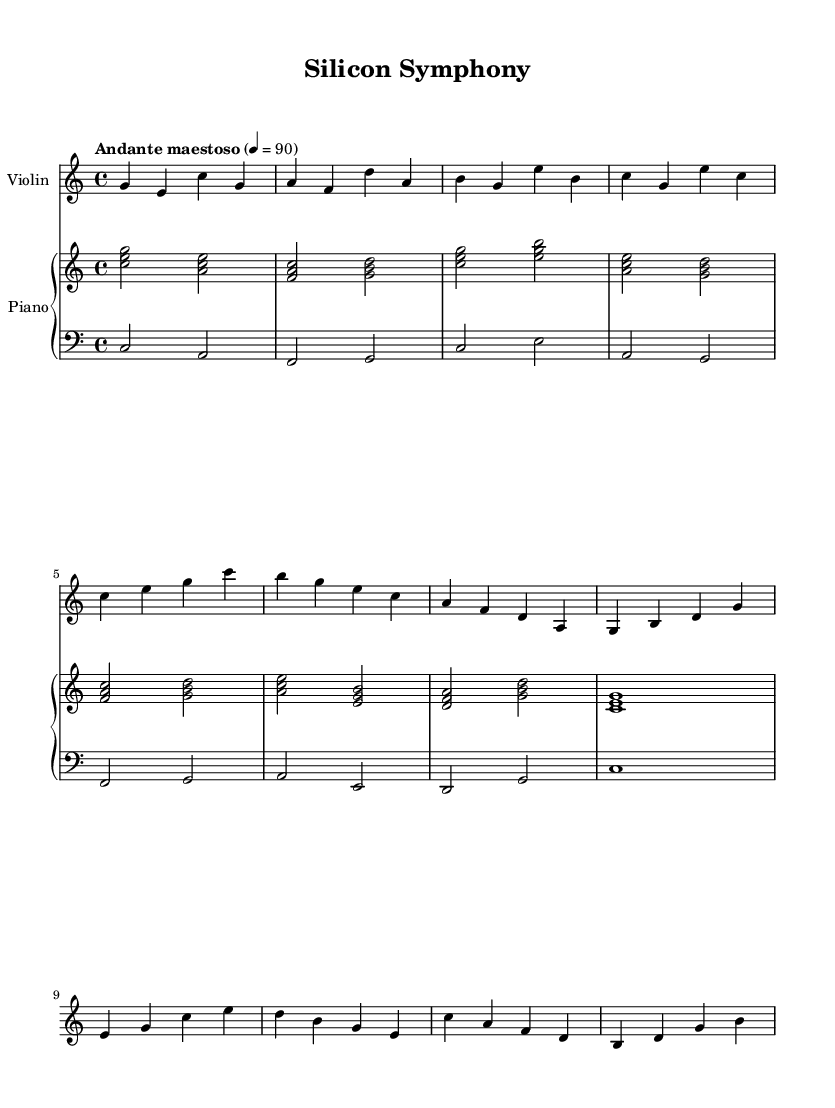What is the key signature of this music? The key signature is C major, which has no sharps or flats.
Answer: C major What is the time signature of this music? The time signature is indicated at the beginning of the score, showing four beats in each measure.
Answer: 4/4 What is the tempo marking for this piece? The tempo is indicated as "Andante maestoso" with a beats-per-minute marking of 90, suggesting a moderately slow and dignified pace.
Answer: Andante maestoso, 90 How many measures are in the first violin part? By counting the measures in the violin part, it is clear that there are a total of 12 measures.
Answer: 12 What is the range of the highest note played by the violin? The highest note in the violin part is c', and it represents the highest pitch played throughout the piece.
Answer: c' Which instrument plays the lowest notes in this score? Examining the score, the piano's bass staff is designated for the lower range, indicating that the piano plays the lowest notes.
Answer: Piano How does the accompaniment in the piano change throughout the piece? The accompaniment in the piano alternates between rhythmic chords in the upper staff and single bass notes in the lower staff, providing a harmonic foundation to the melody.
Answer: Alternates between chords and bass notes 